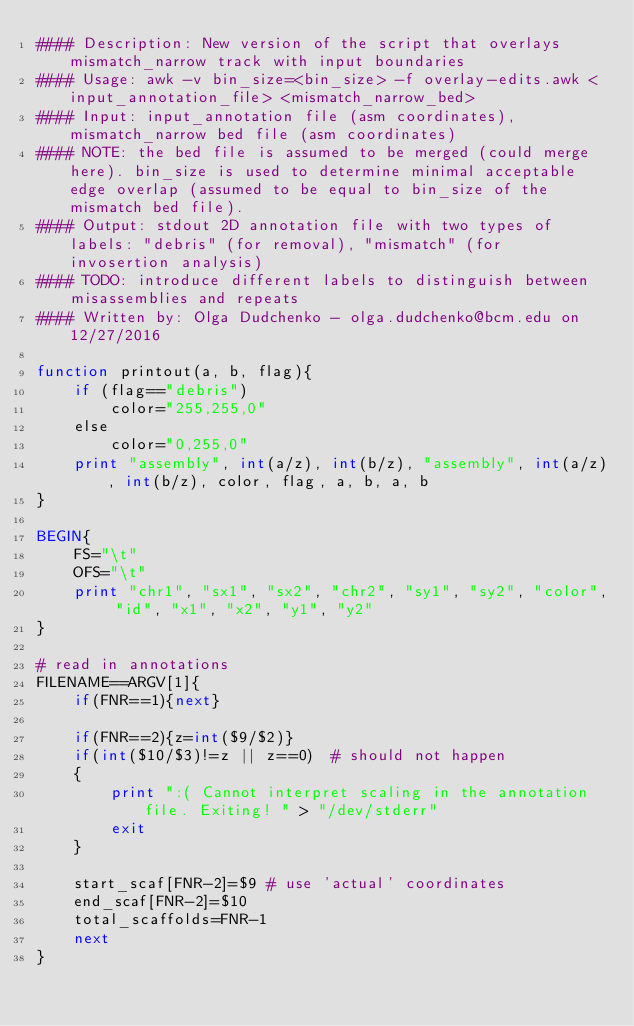Convert code to text. <code><loc_0><loc_0><loc_500><loc_500><_Awk_>#### Description: New version of the script that overlays mismatch_narrow track with input boundaries 
#### Usage: awk -v bin_size=<bin_size> -f overlay-edits.awk <input_annotation_file> <mismatch_narrow_bed>
#### Input: input_annotation file (asm coordinates), mismatch_narrow bed file (asm coordinates)
#### NOTE: the bed file is assumed to be merged (could merge here). bin_size is used to determine minimal acceptable edge overlap (assumed to be equal to bin_size of the mismatch bed file).
#### Output: stdout 2D annotation file with two types of labels: "debris" (for removal), "mismatch" (for invosertion analysis)
#### TODO: introduce different labels to distinguish between misassemblies and repeats
#### Written by: Olga Dudchenko - olga.dudchenko@bcm.edu on 12/27/2016

function printout(a, b, flag){
	if (flag=="debris")
		color="255,255,0"
	else
		color="0,255,0"
	print "assembly", int(a/z), int(b/z), "assembly", int(a/z), int(b/z), color, flag, a, b, a, b 
}

BEGIN{
	FS="\t"
	OFS="\t"
	print "chr1", "sx1", "sx2", "chr2", "sy1", "sy2", "color", "id", "x1", "x2", "y1", "y2"
}

# read in annotations
FILENAME==ARGV[1]{
	if(FNR==1){next}
	
	if(FNR==2){z=int($9/$2)}
	if(int($10/$3)!=z || z==0)	# should not happen
	{
		print ":( Cannot interpret scaling in the annotation file. Exiting! " > "/dev/stderr"
		exit
	}
	
	start_scaf[FNR-2]=$9 # use 'actual' coordinates
	end_scaf[FNR-2]=$10
	total_scaffolds=FNR-1
	next
}</code> 